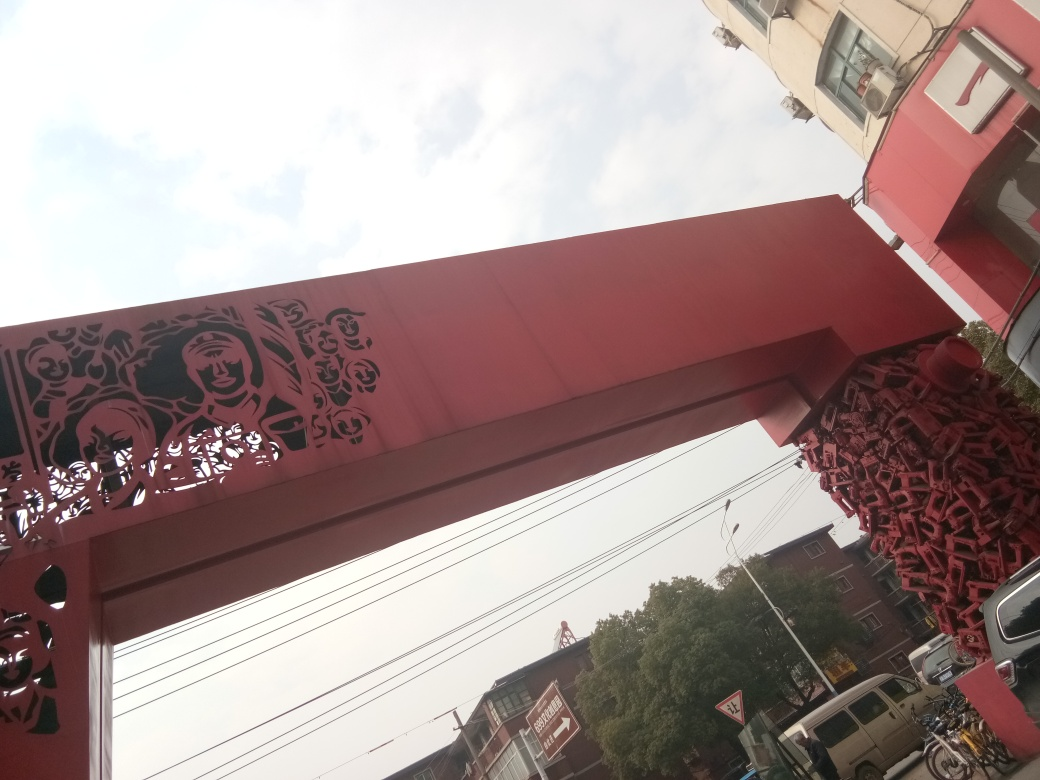How might the weather affect the perception of this image? The overcast weather in the image, indicated by the gray sky, can affect the perception by making the colors appear less vibrant and the overall mood more somber. The lack of strong shadows due to diffused lightning can also result in a flatter image with less contrast between the elements. 